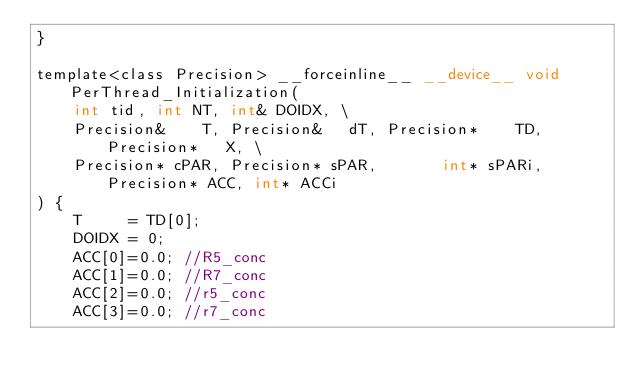Convert code to text. <code><loc_0><loc_0><loc_500><loc_500><_Cuda_>}

template<class Precision> __forceinline__ __device__ void PerThread_Initialization(
    int tid, int NT, int& DOIDX, \
    Precision&    T, Precision&   dT, Precision*    TD, Precision*   X, \
    Precision* cPAR, Precision* sPAR,       int* sPARi, Precision* ACC, int* ACCi
) {
    T     = TD[0];
    DOIDX = 0;
    ACC[0]=0.0; //R5_conc
    ACC[1]=0.0; //R7_conc
    ACC[2]=0.0; //r5_conc
    ACC[3]=0.0; //r7_conc</code> 